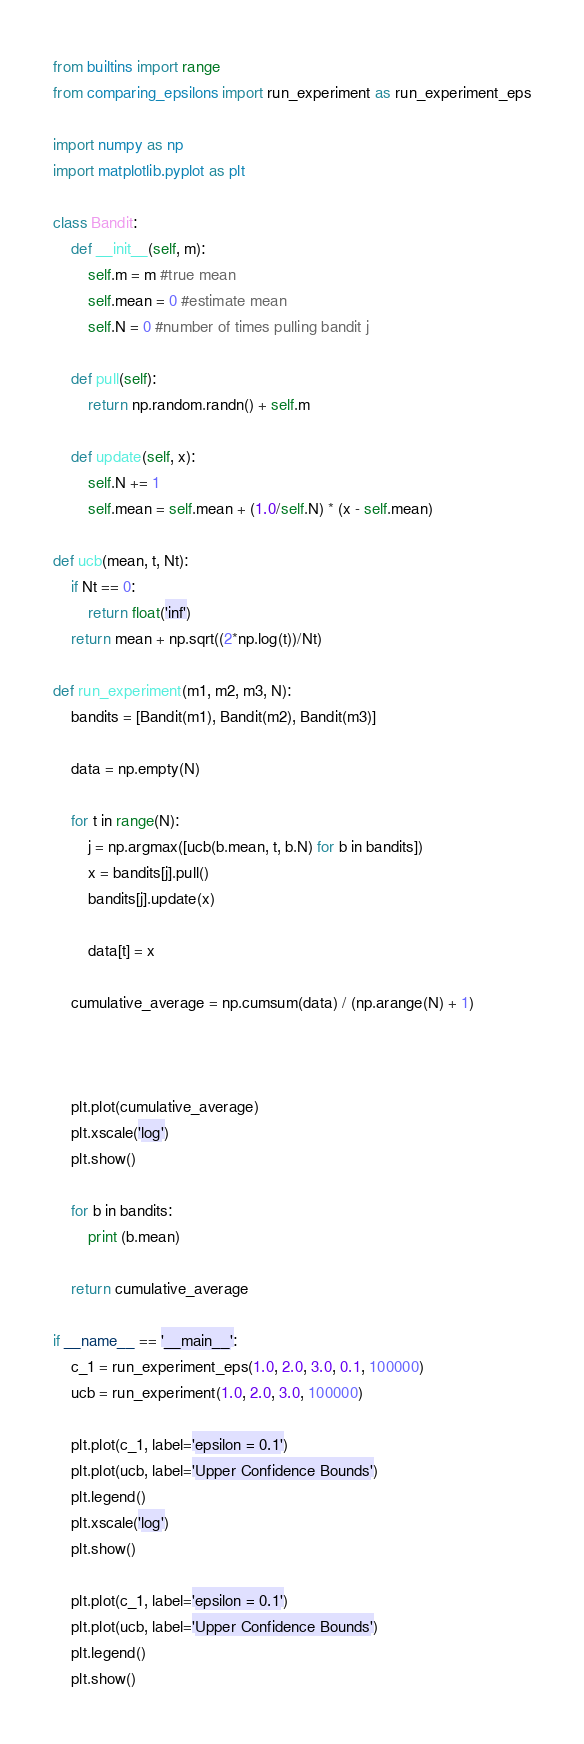Convert code to text. <code><loc_0><loc_0><loc_500><loc_500><_Python_>from builtins import range
from comparing_epsilons import run_experiment as run_experiment_eps

import numpy as np
import matplotlib.pyplot as plt

class Bandit:
    def __init__(self, m):
        self.m = m #true mean
        self.mean = 0 #estimate mean
        self.N = 0 #number of times pulling bandit j

    def pull(self):
        return np.random.randn() + self.m

    def update(self, x):
        self.N += 1
        self.mean = self.mean + (1.0/self.N) * (x - self.mean)

def ucb(mean, t, Nt):
    if Nt == 0:
        return float('inf')
    return mean + np.sqrt((2*np.log(t))/Nt)

def run_experiment(m1, m2, m3, N):
    bandits = [Bandit(m1), Bandit(m2), Bandit(m3)]

    data = np.empty(N)

    for t in range(N):
        j = np.argmax([ucb(b.mean, t, b.N) for b in bandits])
        x = bandits[j].pull()
        bandits[j].update(x)

        data[t] = x

    cumulative_average = np.cumsum(data) / (np.arange(N) + 1)



    plt.plot(cumulative_average)
    plt.xscale('log')
    plt.show()

    for b in bandits:
        print (b.mean)

    return cumulative_average

if __name__ == '__main__':
    c_1 = run_experiment_eps(1.0, 2.0, 3.0, 0.1, 100000)
    ucb = run_experiment(1.0, 2.0, 3.0, 100000)

    plt.plot(c_1, label='epsilon = 0.1')
    plt.plot(ucb, label='Upper Confidence Bounds')
    plt.legend()
    plt.xscale('log')
    plt.show()

    plt.plot(c_1, label='epsilon = 0.1')
    plt.plot(ucb, label='Upper Confidence Bounds')
    plt.legend()
    plt.show()
</code> 